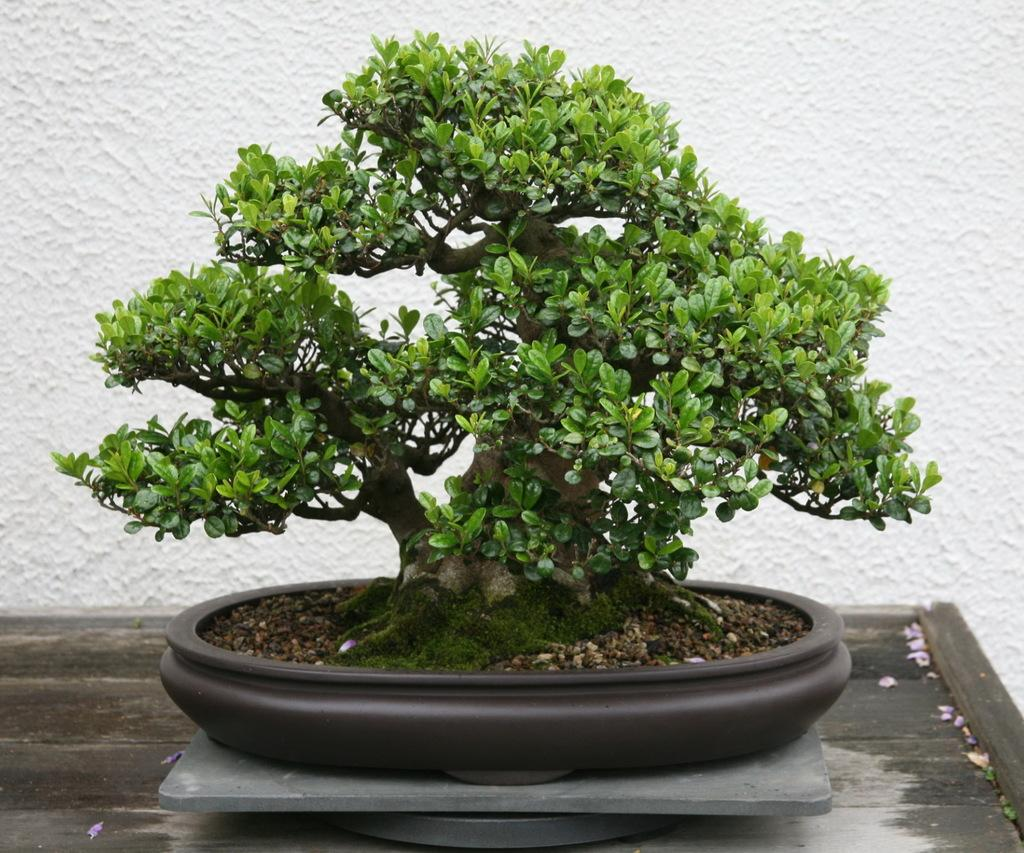What type of plant is in the image? There is a houseplant in the image. What is the houseplant resting on? The houseplant is on a wooden surface. What can be seen behind the plant in the image? There is a wall visible behind the plant. Can you see the mother and chicken playing in the ocean in the image? No, there is no mother, chicken, or ocean present in the image. 